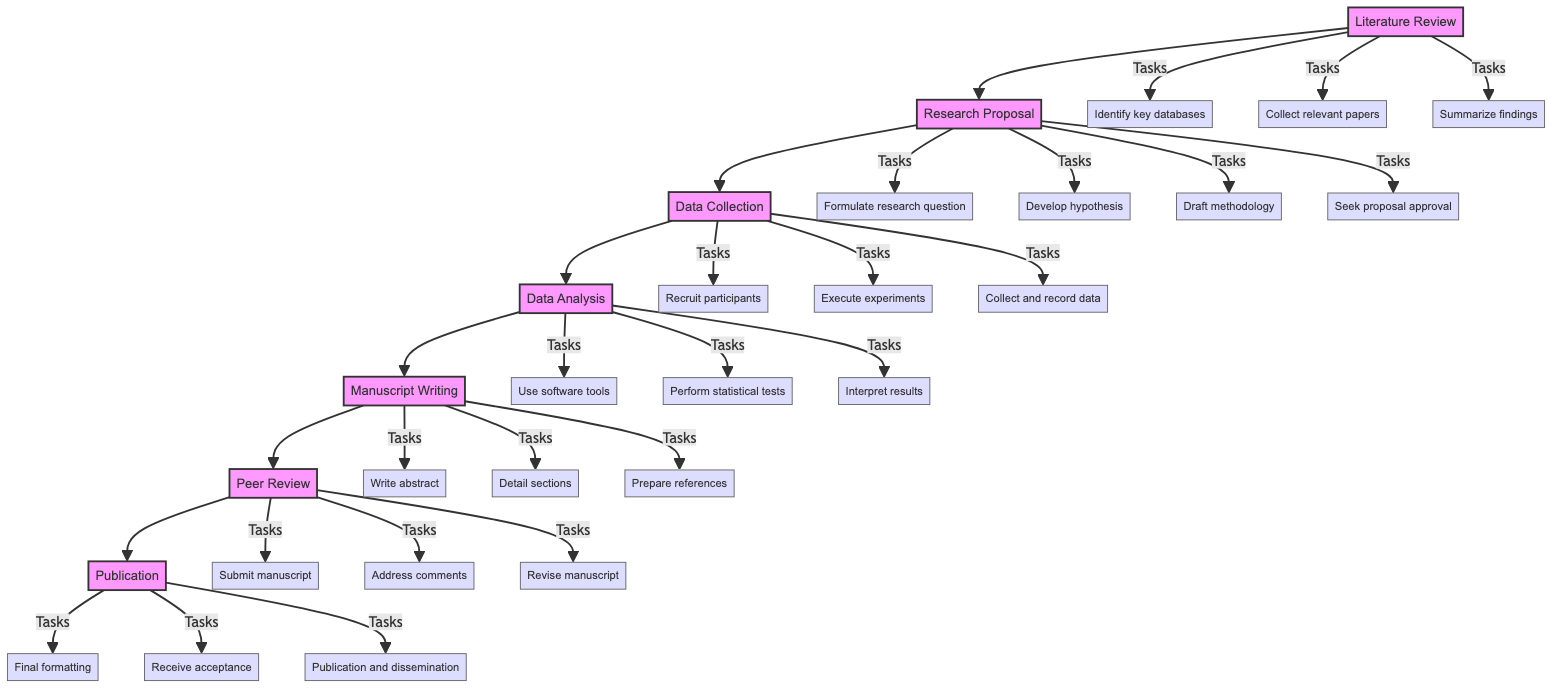What is the first stage in the research workflow? The first stage in the workflow is indicated clearly at the start of the flowchart, labeled "Literature Review." This is the initial task before any other actions are taken in the research process.
Answer: Literature Review How many stages are there in the research workflow? By counting the distinct stages presented in the flowchart, there are seven stages represented from "Literature Review" to "Publication."
Answer: Seven Which stage follows Data Collection? Looking at the directional arrows in the diagram, the arrow leads from "Data Collection" to "Data Analysis," indicating that Data Analysis is the subsequent stage.
Answer: Data Analysis What task is associated with the Research Proposal stage? In the "Research Proposal" stage, one of the tasks listed is "Formulate research question." This task directly relates to developing the proposal.
Answer: Formulate research question If the manuscript is submitted to a journal, which stage is being referred to? The action of submitting the manuscript corresponds to the stage labeled "Peer Review." This indicates the specific process being carried out during this stage.
Answer: Peer Review What task is performed during the Data Analysis stage? Within the "Data Analysis" stage, one of the key tasks is "Use software tools," indicating the technological resources needed for analysis.
Answer: Use software tools What is the last task before publication occurs? Review of the flowchart shows that the last task before the "Publication" stage is "Final formatting of the manuscript," which is crucial before publication can take place.
Answer: Final formatting Which two stages involve writing tasks? The stages that involve writing tasks are "Manuscript Writing" and "Research Proposal," as both include tasks that require document preparation.
Answer: Manuscript Writing and Research Proposal Which stage involves addressing reviewer comments? The stage where reviewer comments are addressed is "Peer Review," as participants in this stage must respond to feedback from peers.
Answer: Peer Review 